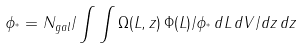<formula> <loc_0><loc_0><loc_500><loc_500>\phi _ { ^ { * } } = N _ { g a l } / \int \int \Omega ( L , z ) \, \Phi ( L ) / \phi _ { ^ { * } } \, d L \, d V / d z \, d z</formula> 